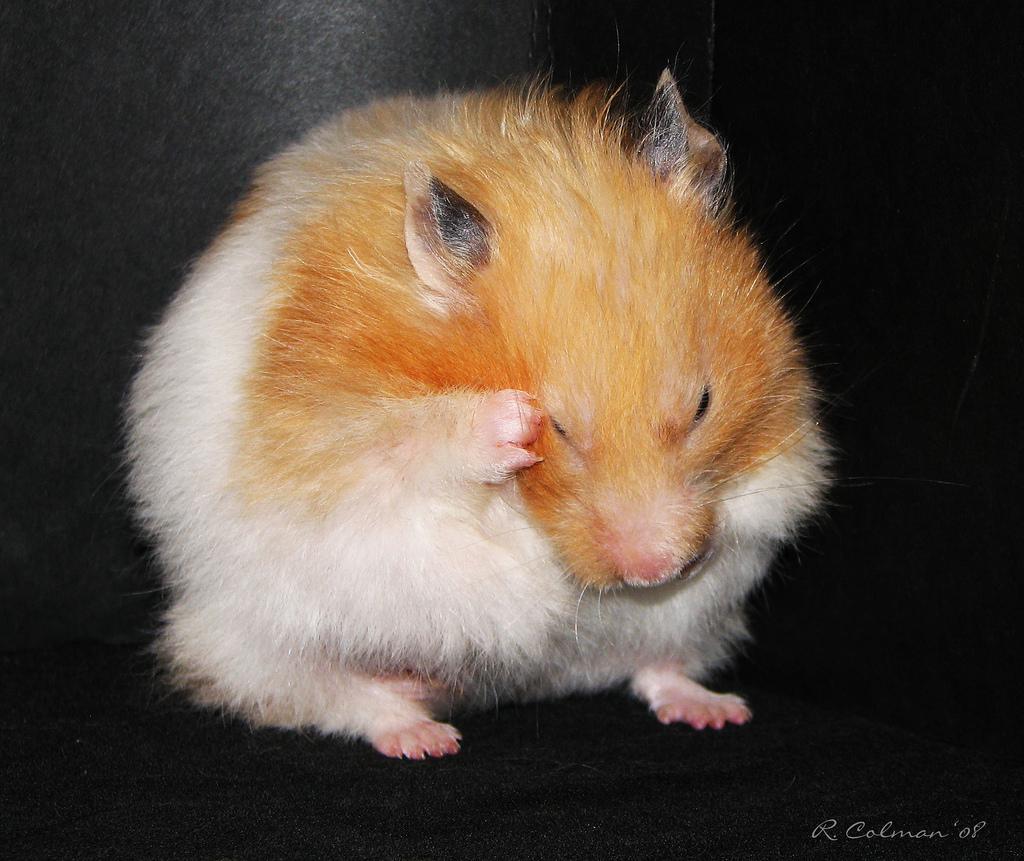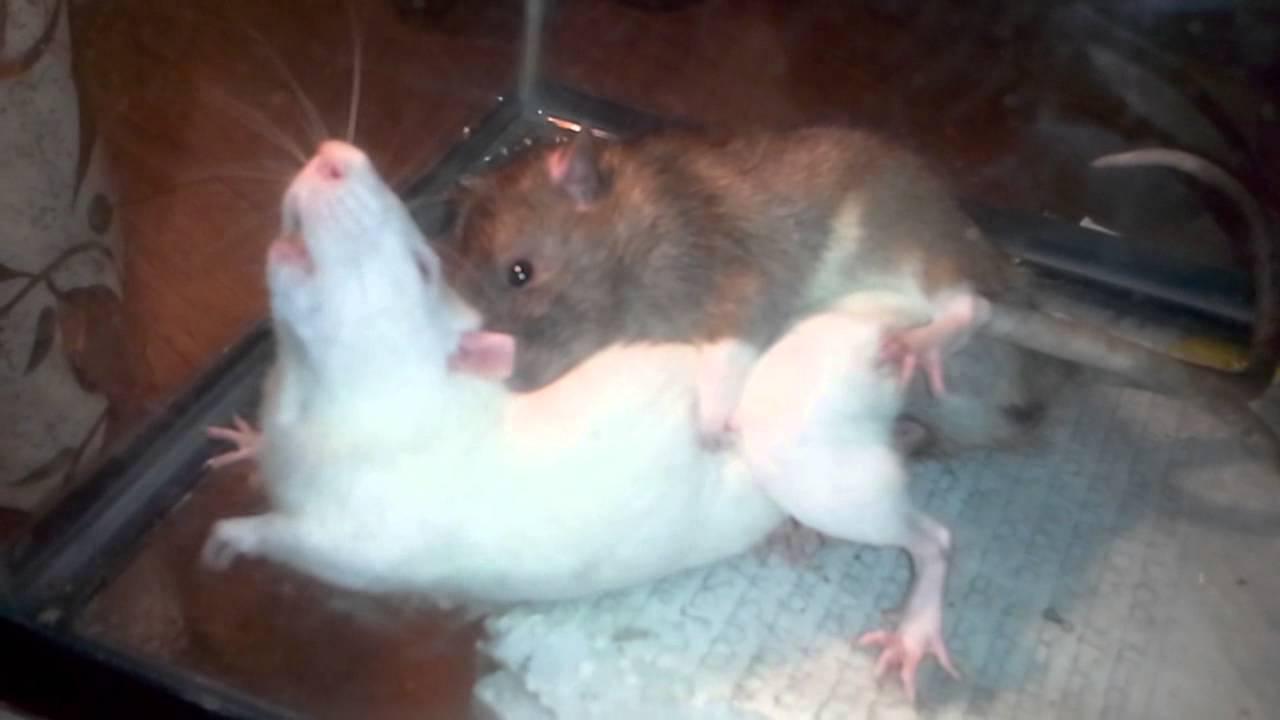The first image is the image on the left, the second image is the image on the right. For the images shown, is this caption "one animal is on top of the other in the right side image" true? Answer yes or no. Yes. 